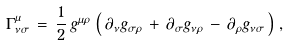<formula> <loc_0><loc_0><loc_500><loc_500>\Gamma ^ { \mu } _ { \nu \sigma } \, = \, \frac { 1 } { 2 } \, g ^ { \mu \rho } \, \left ( \, \partial _ { \nu } g _ { \sigma \rho } \, + \, \partial _ { \sigma } g _ { \nu \rho } \, - \, \partial _ { \rho } g _ { \nu \sigma } \, \right ) \, ,</formula> 